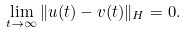Convert formula to latex. <formula><loc_0><loc_0><loc_500><loc_500>\lim _ { t \rightarrow \infty } \| u ( t ) - v ( t ) \| _ { H } = 0 .</formula> 